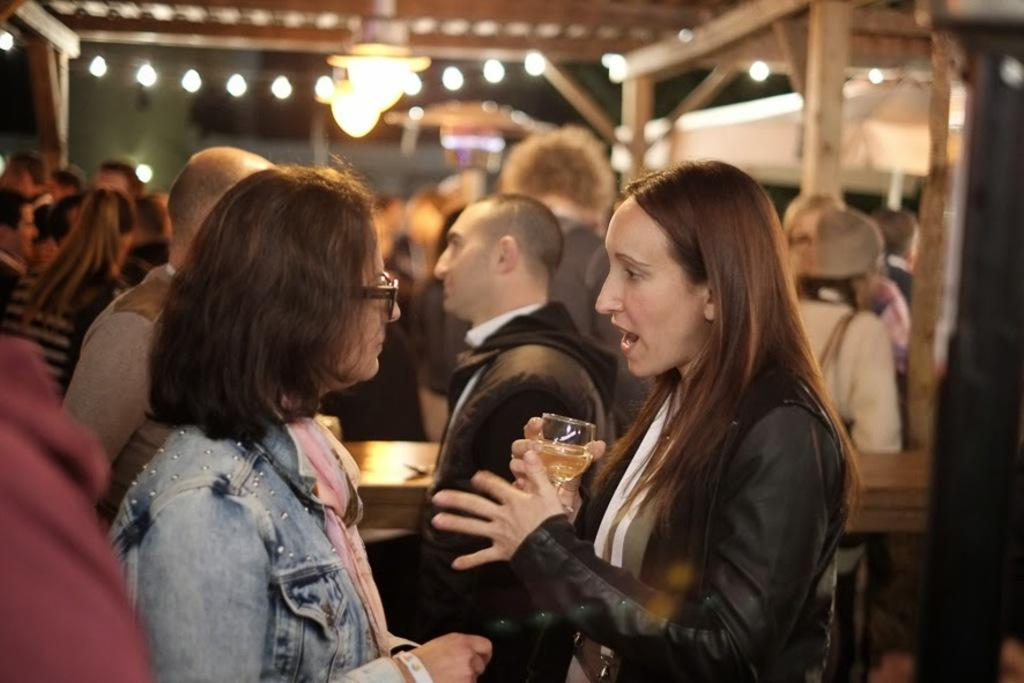How many people are in the image? There is a group of people in the image. What is one person holding in the image? One person is holding a glass. What can be seen in the image that provides illumination? There are lights visible in the image. What is the appearance of the background in the image? The background of the image is blurred. How many plastic beetles are crawling on the babies in the image? There are no babies or plastic beetles present in the image. 